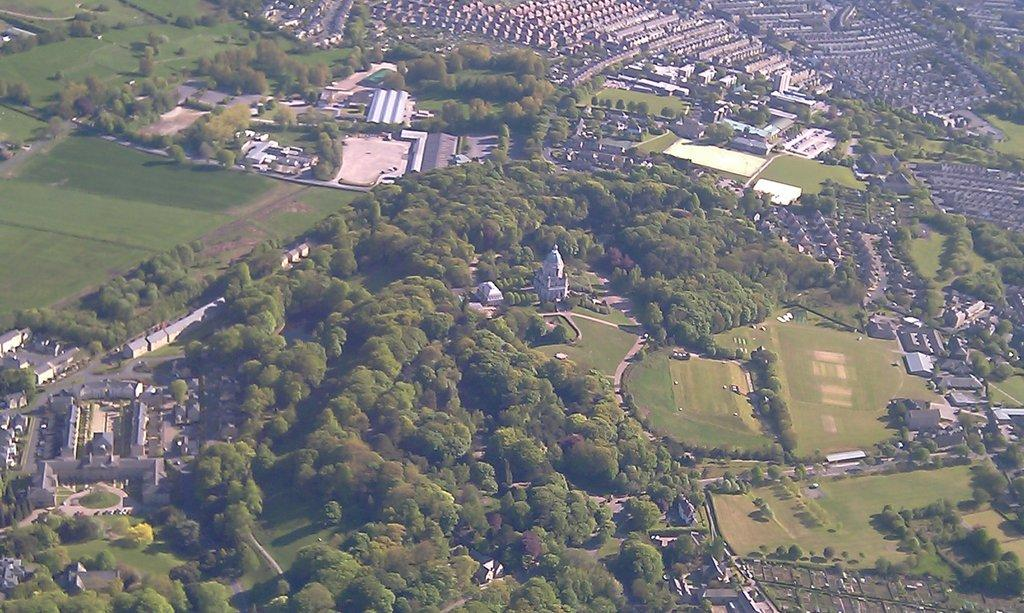What type of view is depicted in the image? The image is an aerial view. What natural elements can be seen in the image? There are trees in the image. What type of landscape is visible in the image? There are fields in the image. What man-made structures are present in the image? There are buildings in the image. What design is featured on the parent's shirt in the image? There are no people or clothing items present in the image, so it is not possible to answer that question. 